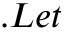<formula> <loc_0><loc_0><loc_500><loc_500>. L e t</formula> 